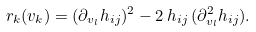<formula> <loc_0><loc_0><loc_500><loc_500>r _ { k } ( v _ { k } ) = ( \partial _ { v _ { l } } h _ { i j } ) ^ { 2 } - 2 \, h _ { i j } \, ( \partial _ { v _ { l } } ^ { 2 } h _ { i j } ) .</formula> 